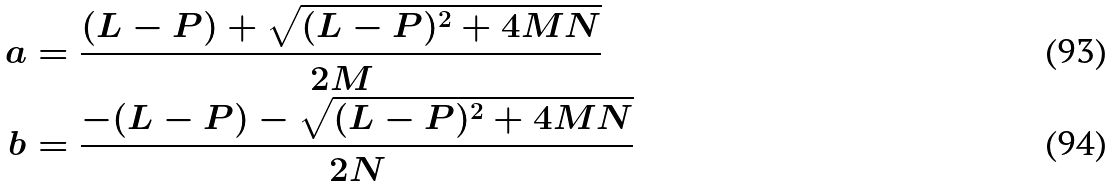Convert formula to latex. <formula><loc_0><loc_0><loc_500><loc_500>a & = \frac { ( L - P ) + \sqrt { ( L - P ) ^ { 2 } + 4 M N } } { 2 M } \\ b & = \frac { - ( L - P ) - \sqrt { ( L - P ) ^ { 2 } + 4 M N } } { 2 N } \</formula> 